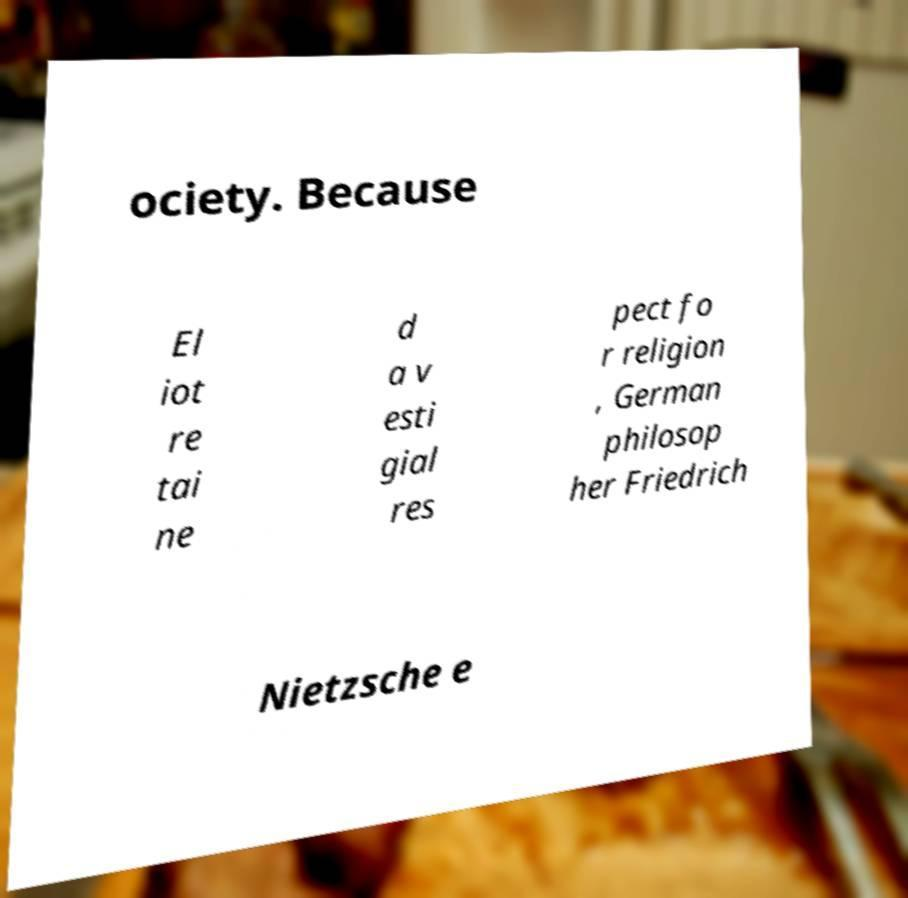Could you extract and type out the text from this image? ociety. Because El iot re tai ne d a v esti gial res pect fo r religion , German philosop her Friedrich Nietzsche e 